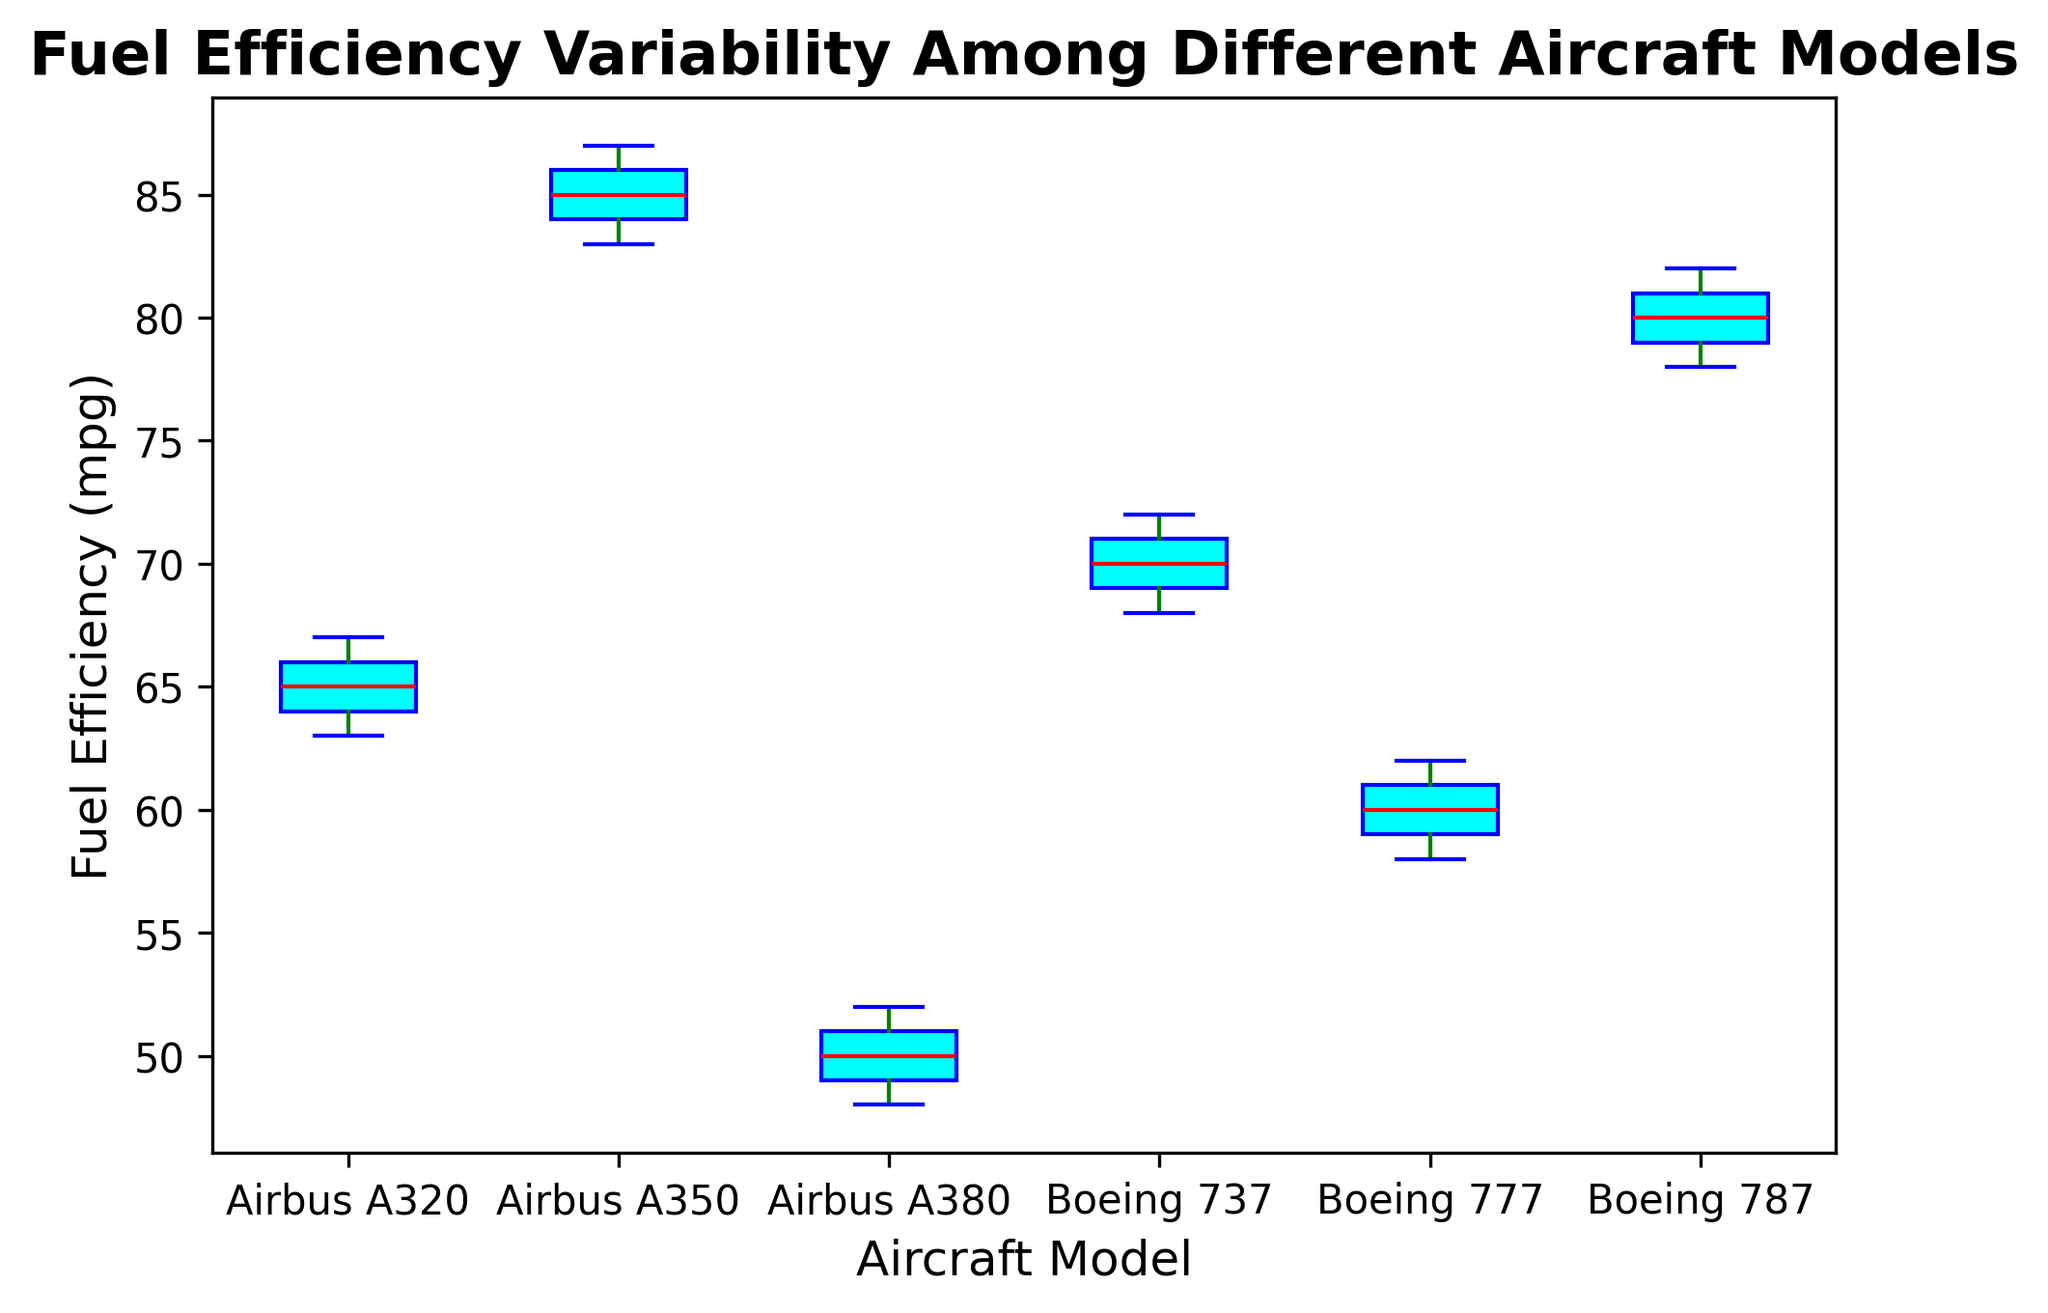What's the median fuel efficiency of the Airbus A320? To find the median fuel efficiency, locate the middle value when the data points are arranged in ascending order. The values for Airbus A320 are (63, 64, 65, 66, 67), so the median is 65.
Answer: 65 Which aircraft model shows the highest median fuel efficiency? Look at the median lines in the box plots for each aircraft model. The Airbus A350 has the highest median fuel efficiency.
Answer: Airbus A350 How does the fuel efficiency variability of the Boeing 777 compare to the Airbus A380? Compare the lengths of the boxes (interquartile ranges) and the whiskers (total range) for the two models. Both models have fairly similar ranges, but the Boeing 777 has a slightly larger spread in the interquartile range compared to the Airbus A380.
Answer: Boeing 777 has larger variability What is the difference between the median fuel efficiencies of the Boeing 787 and the Boeing 737? Find the median values for both Boeing 787 and Boeing 737 and then subtract the median of Boeing 737 from the median of Boeing 787. The medians are approximately 80 and 70 respectively, so the difference is 10.
Answer: 10 Which aircraft model has the smallest interquartile range (IQR) of fuel efficiency? Examine the boxes’ heights, which represent the IQR, across all aircraft models. The Airbus A380 has the smallest IQR.
Answer: Airbus A380 Is the median fuel efficiency of the Airbus A350 greater than that of the Boeing 787? Compare the median lines in the box plots for these two models. The Airbus A350's median (85) is greater than the Boeing 787's median (80).
Answer: Yes What is the range of fuel efficiencies observed for the Boeing 737? Determine the minimum and maximum whisker ends for the Boeing 737. The values are 68 (min) and 72 (max), so the range is 72 - 68 = 4.
Answer: 4 Between which two aircraft models is the median fuel efficiency relatively close? Compare the median lines to find two aircraft models with similar median values. The Boeing 737 and Airbus A320 have relatively close medians, around 70 and 65, respectively.
Answer: Boeing 737 and Airbus A320 